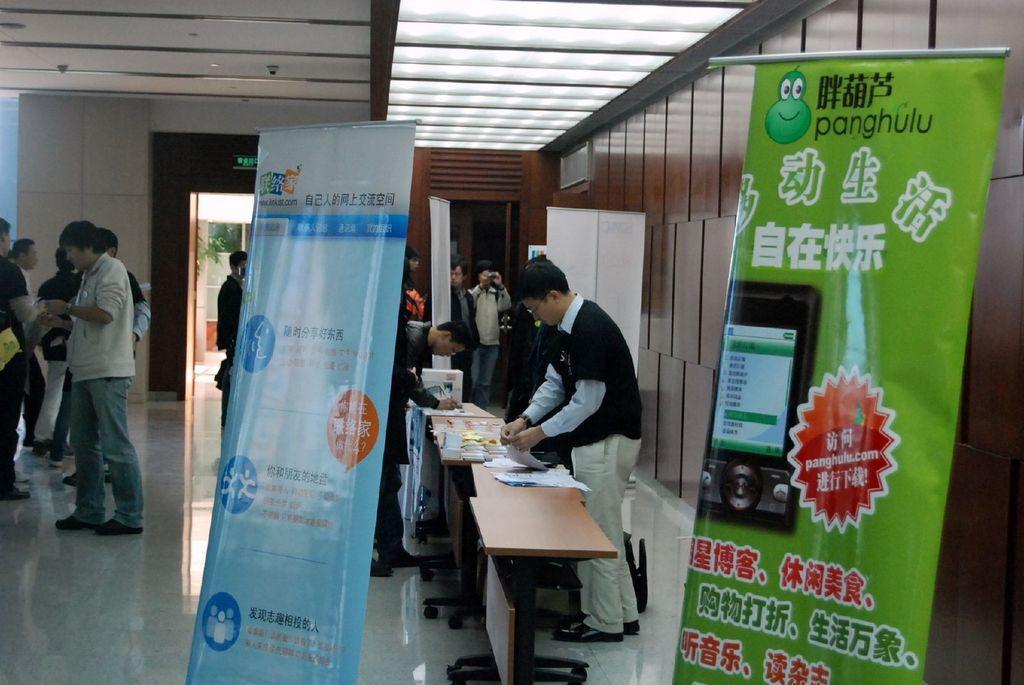How would you summarize this image in a sentence or two? In a room there are tables and men standing around them. There are two banners in a room. 